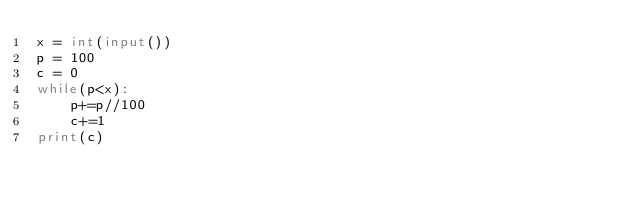<code> <loc_0><loc_0><loc_500><loc_500><_Python_>x = int(input())
p = 100
c = 0
while(p<x):
    p+=p//100
    c+=1
print(c)</code> 